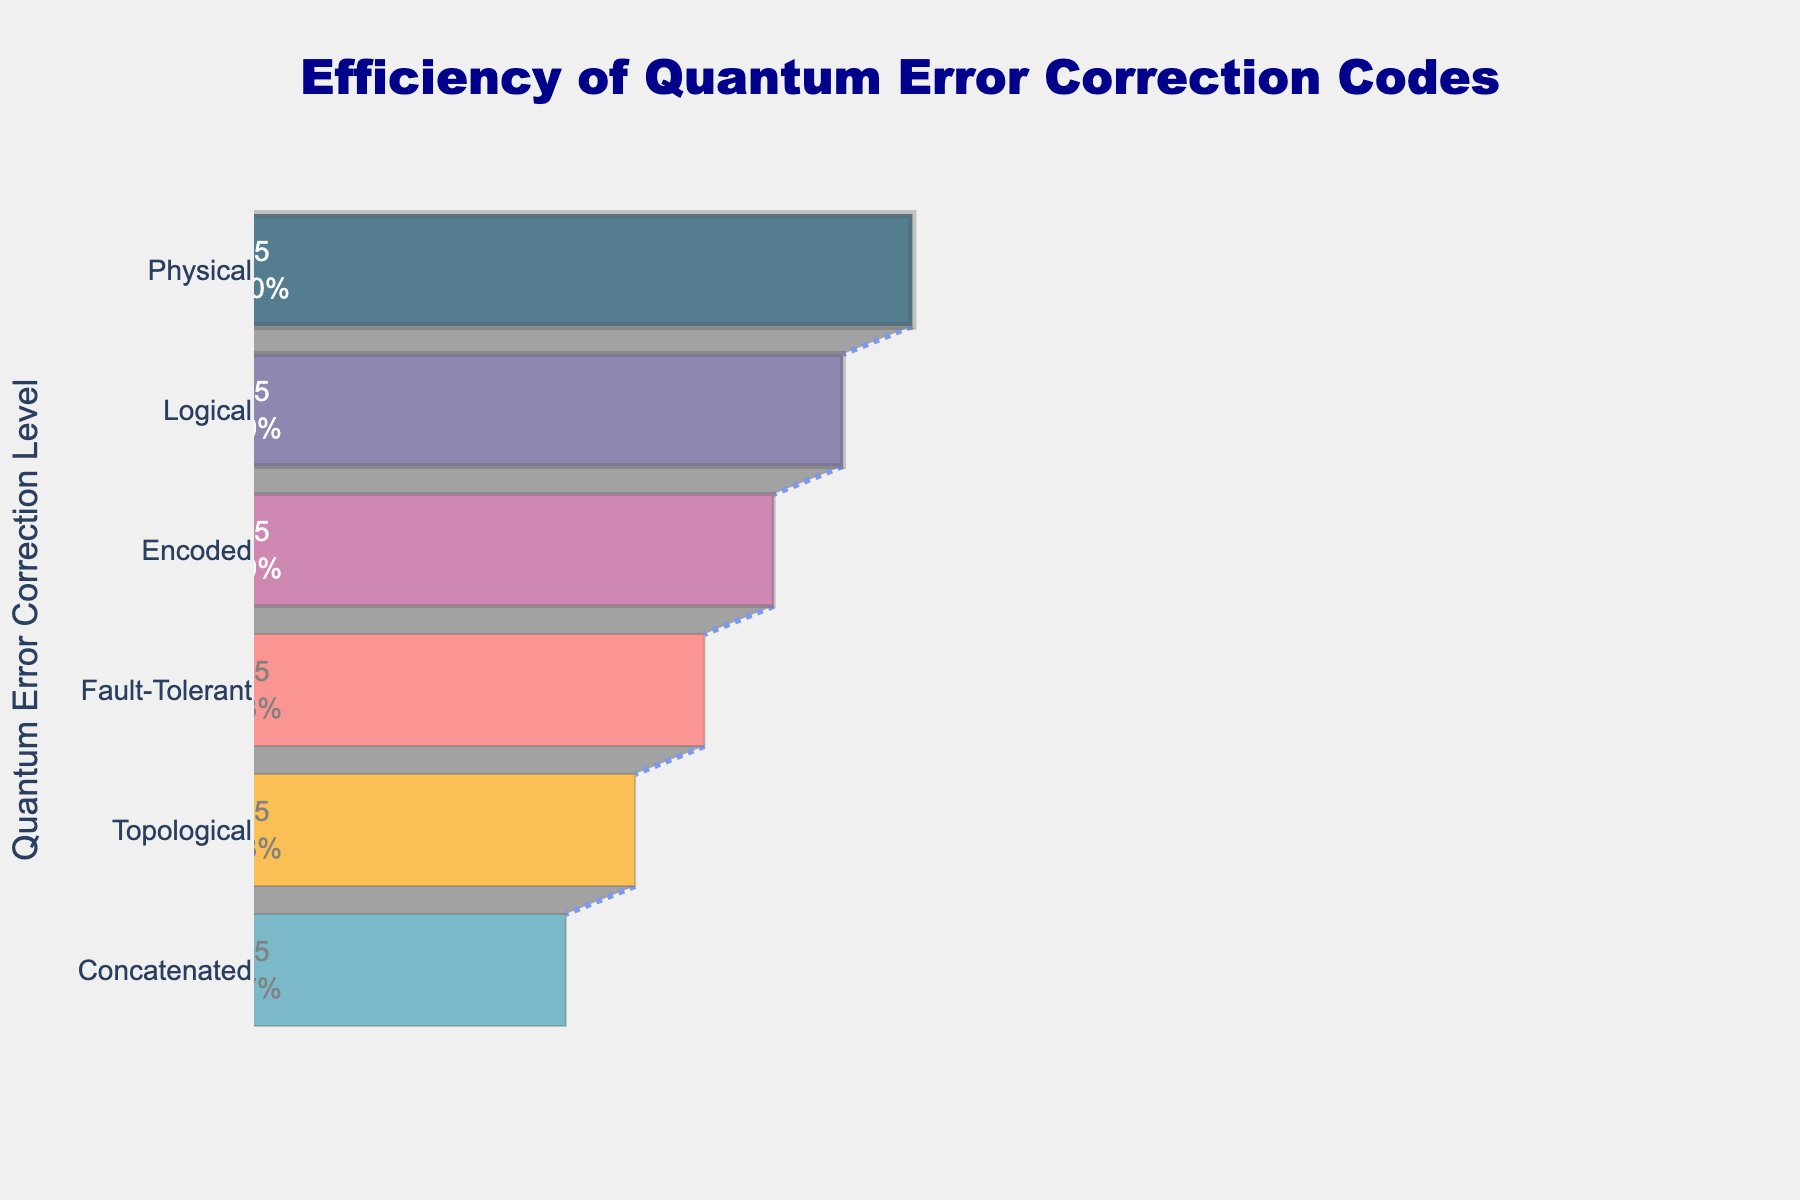what is the title of the chart? The title of the chart is located at the top center and reads "Efficiency of Quantum Error Correction Codes"
Answer: Efficiency of Quantum Error Correction Codes How many levels of Quantum Error Correction Codes are represented in the chart? The chart lists the levels of Quantum Error Correction Codes on the y-axis. By counting the entries, we identify there are six levels.
Answer: Six Which Quantum Error Correction Code has the highest efficiency? By looking at the funnel chart, the top section represents the level with the highest efficiency. The "Physical" level with the "Surface Code" label shows the highest efficiency at 95%.
Answer: Surface Code What is the efficiency of the "Encoded" level? The chart includes a section labeled "Encoded," which shows the efficiency for this level as 75%.
Answer: 75% Which Quantum Error Correction Code has the lowest efficiency? The chart’s bottom section represents the level with the lowest efficiency. The "Concatenated" level with the "Reed-Muller Code" label shows the lowest efficiency at 45%.
Answer: Reed-Muller Code How much higher is the efficiency of the "Logical" level compared to the "Topological" level? The efficiencies for the "Logical" and "Topological" levels are 85% and 55%, respectively. The difference is calculated as 85% - 55%.
Answer: 30% What percentage of efficiency is lost from the highest (Surface Code) to the lowest (Reed-Muller Code) level? The efficiency of the highest level is 95%, and the lowest is 45%. The percentage lost is calculated as 95% - 45%.
Answer: 50% What is the average efficiency of all the Quantum Error Correction Codes combined? Adding up the efficiencies (95 + 85 + 75 + 65 + 55 + 45) gives 420. Dividing by the number of levels (6) results in an average efficiency of 70%.
Answer: 70% Is there any level with an efficiency equal to 55%? By examining the funnel chart, the "Topological" level displays an efficiency of 55%.
Answer: Yes How does the color of the levels change as efficiency decreases? Observing the funnel chart, the color gradient transitions from a dark purple (#003f5c) at high efficiency to a lighter yellow (#ffa600) at lower efficiency levels.
Answer: From purple to yellow 